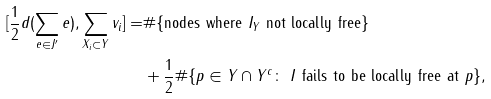Convert formula to latex. <formula><loc_0><loc_0><loc_500><loc_500>[ \frac { 1 } { 2 } d ( \sum _ { e \in J ^ { \prime } } e ) , \sum _ { X _ { i } \subset Y } v _ { i } ] = & \# \{ \text {nodes where $I_{Y}$ not locally free} \} \\ & + \frac { 1 } { 2 } \# \{ p \in Y \cap Y ^ { c } \colon \text { $I$ fails to be locally free at $p$} \} ,</formula> 